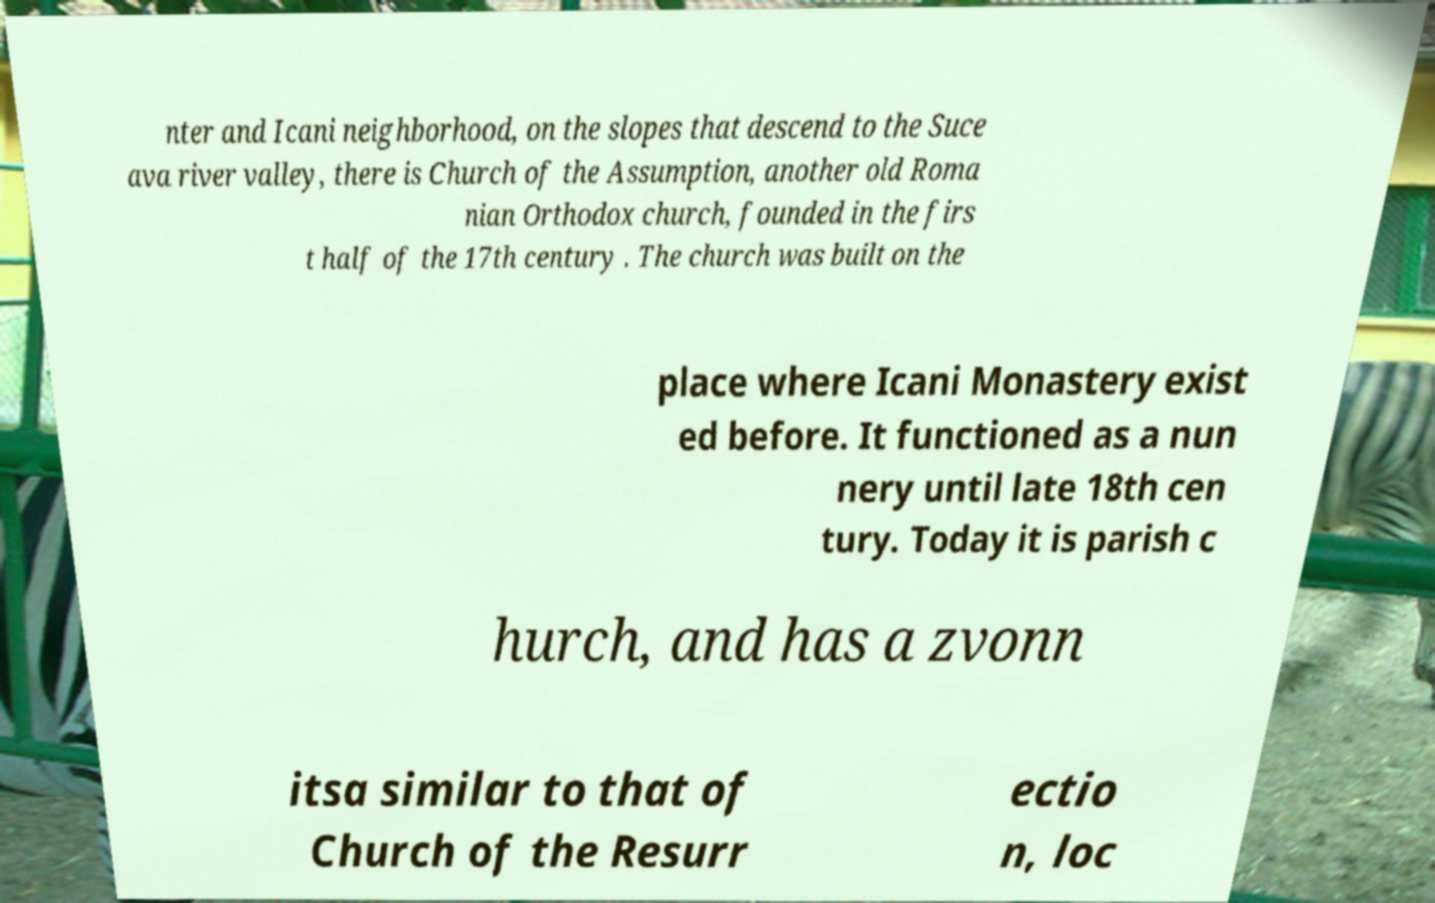Please identify and transcribe the text found in this image. nter and Icani neighborhood, on the slopes that descend to the Suce ava river valley, there is Church of the Assumption, another old Roma nian Orthodox church, founded in the firs t half of the 17th century . The church was built on the place where Icani Monastery exist ed before. It functioned as a nun nery until late 18th cen tury. Today it is parish c hurch, and has a zvonn itsa similar to that of Church of the Resurr ectio n, loc 